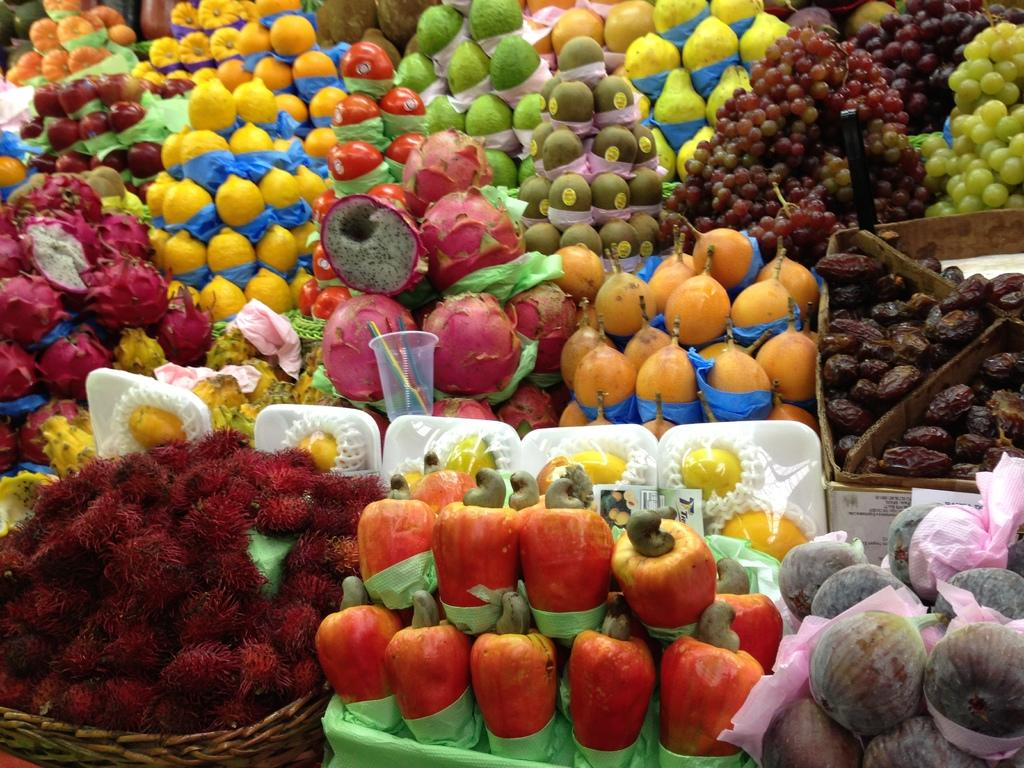What types of food items are present in the image? There are numerous fruits in the image. What is the leg of the table doing in the image? There is no table or leg mentioned in the image; it only contains numerous fruits. 